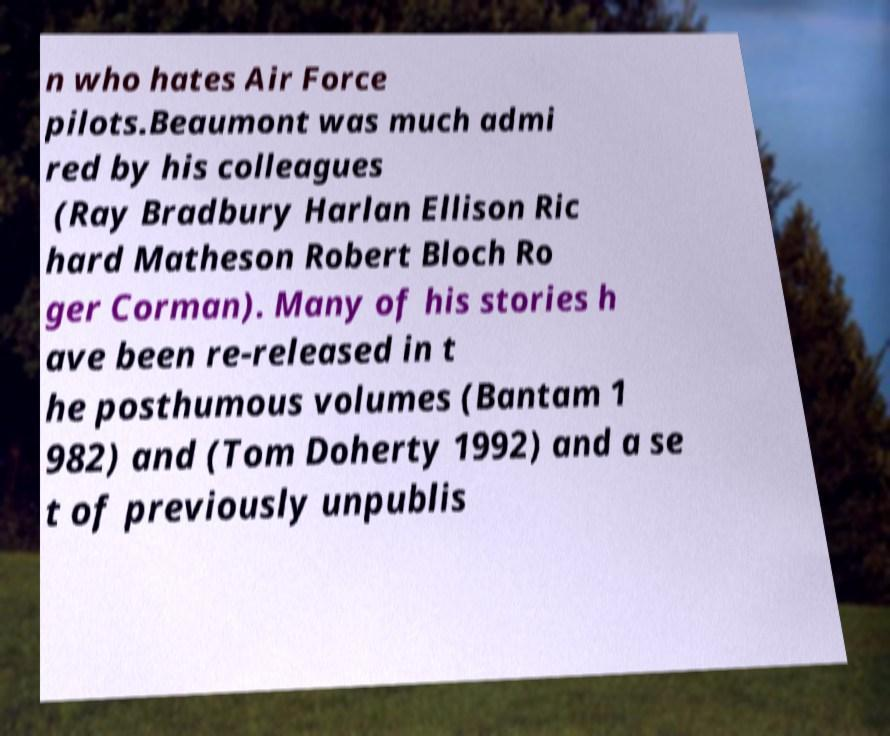For documentation purposes, I need the text within this image transcribed. Could you provide that? n who hates Air Force pilots.Beaumont was much admi red by his colleagues (Ray Bradbury Harlan Ellison Ric hard Matheson Robert Bloch Ro ger Corman). Many of his stories h ave been re-released in t he posthumous volumes (Bantam 1 982) and (Tom Doherty 1992) and a se t of previously unpublis 